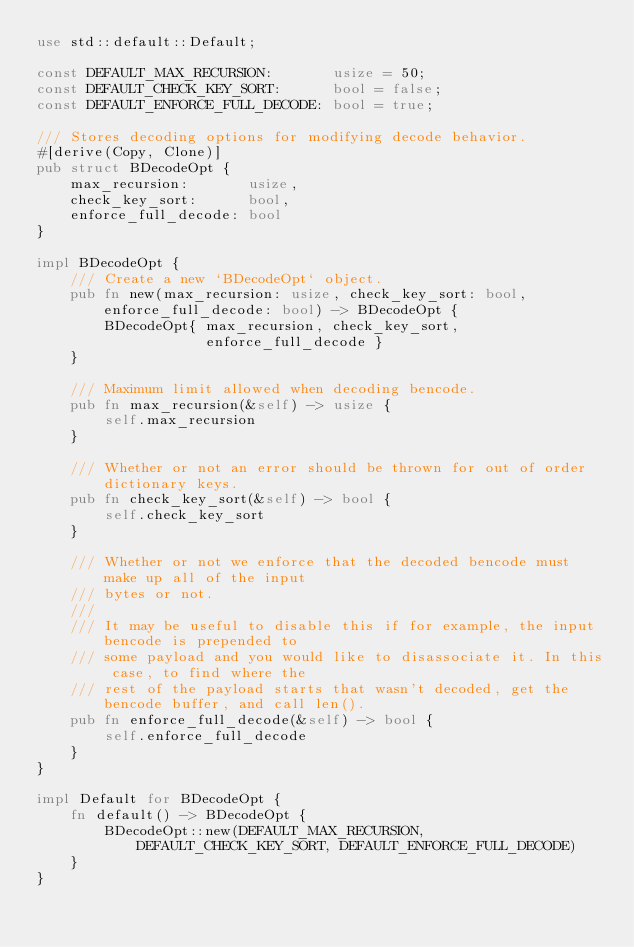<code> <loc_0><loc_0><loc_500><loc_500><_Rust_>use std::default::Default;

const DEFAULT_MAX_RECURSION:       usize = 50;
const DEFAULT_CHECK_KEY_SORT:      bool = false;
const DEFAULT_ENFORCE_FULL_DECODE: bool = true;

/// Stores decoding options for modifying decode behavior.
#[derive(Copy, Clone)]
pub struct BDecodeOpt {
    max_recursion:       usize,
    check_key_sort:      bool,
    enforce_full_decode: bool
}

impl BDecodeOpt {
    /// Create a new `BDecodeOpt` object.
    pub fn new(max_recursion: usize, check_key_sort: bool, enforce_full_decode: bool) -> BDecodeOpt {
        BDecodeOpt{ max_recursion, check_key_sort,
                    enforce_full_decode }
    }

    /// Maximum limit allowed when decoding bencode.
    pub fn max_recursion(&self) -> usize {
        self.max_recursion
    }

    /// Whether or not an error should be thrown for out of order dictionary keys.
    pub fn check_key_sort(&self) -> bool {
        self.check_key_sort
    }

    /// Whether or not we enforce that the decoded bencode must make up all of the input
    /// bytes or not.
    ///
    /// It may be useful to disable this if for example, the input bencode is prepended to
    /// some payload and you would like to disassociate it. In this case, to find where the
    /// rest of the payload starts that wasn't decoded, get the bencode buffer, and call len().
    pub fn enforce_full_decode(&self) -> bool {
        self.enforce_full_decode
    }
}

impl Default for BDecodeOpt {
    fn default() -> BDecodeOpt {
        BDecodeOpt::new(DEFAULT_MAX_RECURSION, DEFAULT_CHECK_KEY_SORT, DEFAULT_ENFORCE_FULL_DECODE)
    }
}</code> 